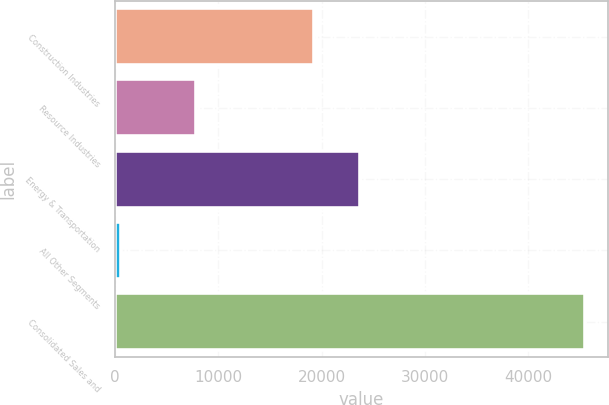Convert chart to OTSL. <chart><loc_0><loc_0><loc_500><loc_500><bar_chart><fcel>Construction Industries<fcel>Resource Industries<fcel>Energy & Transportation<fcel>All Other Segments<fcel>Consolidated Sales and<nl><fcel>19240<fcel>7861<fcel>23729.2<fcel>570<fcel>45462<nl></chart> 